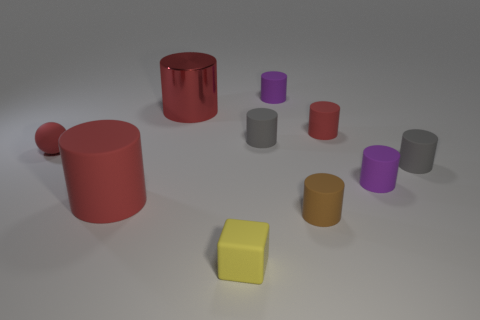Subtract all red cylinders. How many were subtracted if there are1red cylinders left? 2 Subtract all big matte cylinders. How many cylinders are left? 7 Subtract all red cylinders. How many cylinders are left? 5 Subtract all blocks. How many objects are left? 9 Add 9 small brown matte cylinders. How many small brown matte cylinders are left? 10 Add 3 purple cylinders. How many purple cylinders exist? 5 Subtract 0 cyan spheres. How many objects are left? 10 Subtract all gray cylinders. Subtract all red spheres. How many cylinders are left? 6 Subtract all yellow balls. How many brown cylinders are left? 1 Subtract all cyan metallic blocks. Subtract all small purple things. How many objects are left? 8 